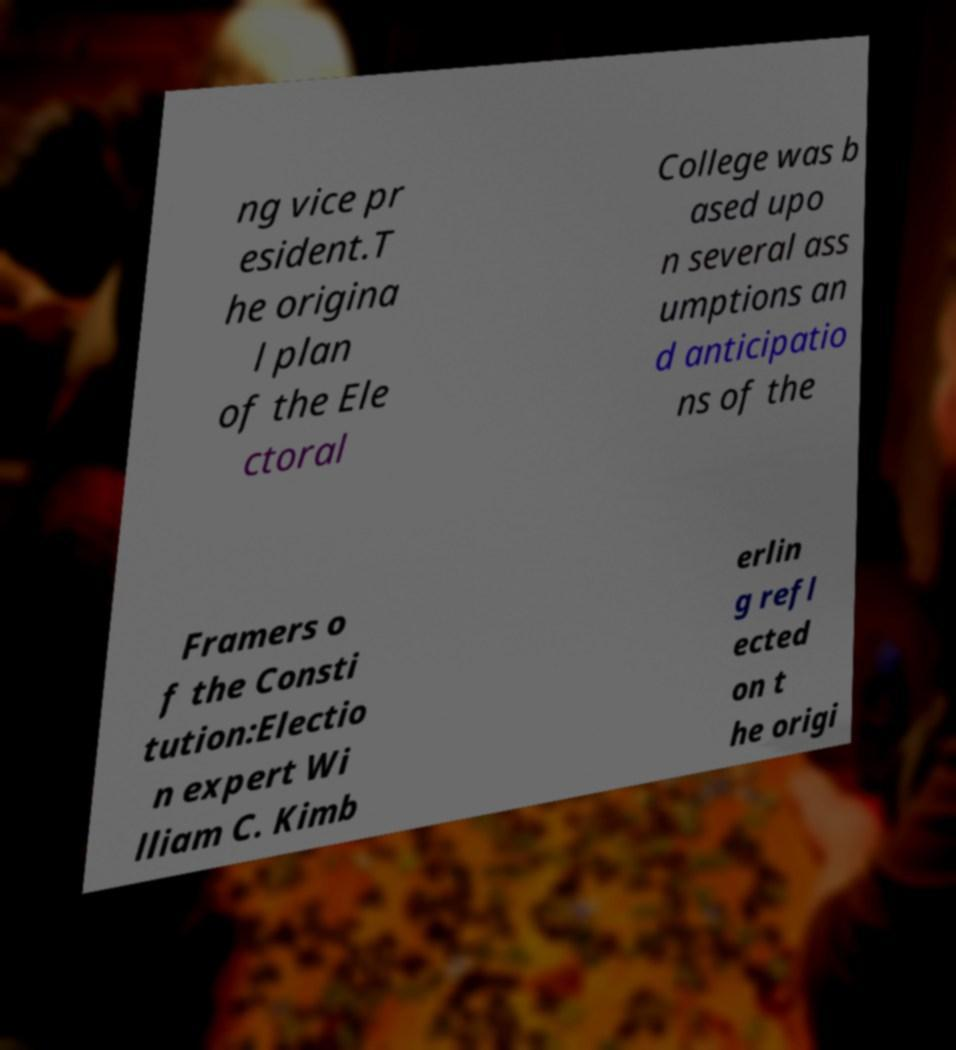Could you extract and type out the text from this image? ng vice pr esident.T he origina l plan of the Ele ctoral College was b ased upo n several ass umptions an d anticipatio ns of the Framers o f the Consti tution:Electio n expert Wi lliam C. Kimb erlin g refl ected on t he origi 